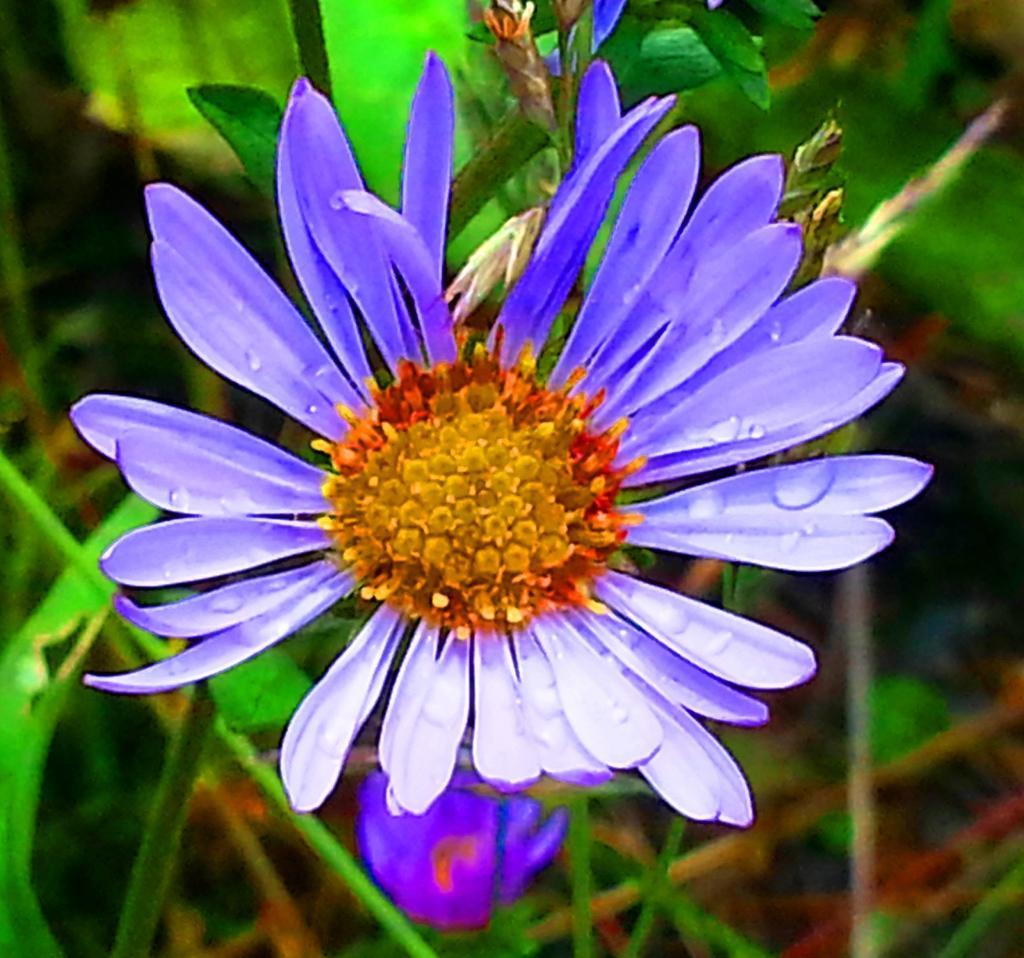What is the main subject in the center of the image? There is a flower in the center of the image. What can be seen in the background of the image? There is greenery in the background of the image. What type of arm is visible in the image? There is no arm present in the image; it features a flower and greenery. 